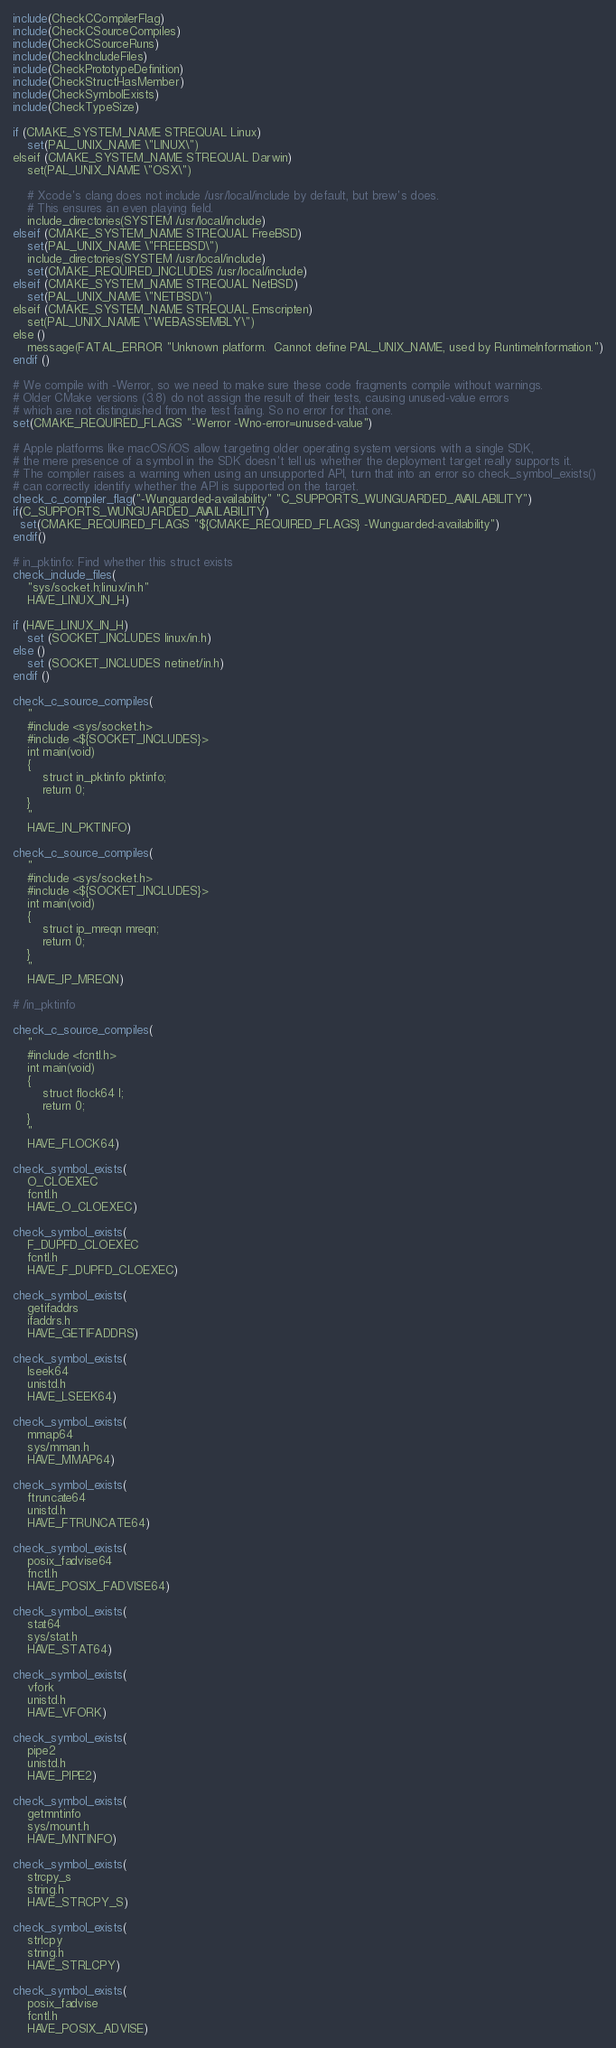Convert code to text. <code><loc_0><loc_0><loc_500><loc_500><_CMake_>include(CheckCCompilerFlag)
include(CheckCSourceCompiles)
include(CheckCSourceRuns)
include(CheckIncludeFiles)
include(CheckPrototypeDefinition)
include(CheckStructHasMember)
include(CheckSymbolExists)
include(CheckTypeSize)

if (CMAKE_SYSTEM_NAME STREQUAL Linux)
    set(PAL_UNIX_NAME \"LINUX\")
elseif (CMAKE_SYSTEM_NAME STREQUAL Darwin)
    set(PAL_UNIX_NAME \"OSX\")

    # Xcode's clang does not include /usr/local/include by default, but brew's does.
    # This ensures an even playing field.
    include_directories(SYSTEM /usr/local/include)
elseif (CMAKE_SYSTEM_NAME STREQUAL FreeBSD)
    set(PAL_UNIX_NAME \"FREEBSD\")
    include_directories(SYSTEM /usr/local/include)
    set(CMAKE_REQUIRED_INCLUDES /usr/local/include)
elseif (CMAKE_SYSTEM_NAME STREQUAL NetBSD)
    set(PAL_UNIX_NAME \"NETBSD\")
elseif (CMAKE_SYSTEM_NAME STREQUAL Emscripten)
    set(PAL_UNIX_NAME \"WEBASSEMBLY\")
else ()
    message(FATAL_ERROR "Unknown platform.  Cannot define PAL_UNIX_NAME, used by RuntimeInformation.")
endif ()

# We compile with -Werror, so we need to make sure these code fragments compile without warnings.
# Older CMake versions (3.8) do not assign the result of their tests, causing unused-value errors
# which are not distinguished from the test failing. So no error for that one.
set(CMAKE_REQUIRED_FLAGS "-Werror -Wno-error=unused-value")

# Apple platforms like macOS/iOS allow targeting older operating system versions with a single SDK,
# the mere presence of a symbol in the SDK doesn't tell us whether the deployment target really supports it.
# The compiler raises a warning when using an unsupported API, turn that into an error so check_symbol_exists()
# can correctly identify whether the API is supported on the target.
check_c_compiler_flag("-Wunguarded-availability" "C_SUPPORTS_WUNGUARDED_AVAILABILITY")
if(C_SUPPORTS_WUNGUARDED_AVAILABILITY)
  set(CMAKE_REQUIRED_FLAGS "${CMAKE_REQUIRED_FLAGS} -Wunguarded-availability")
endif()

# in_pktinfo: Find whether this struct exists
check_include_files(
    "sys/socket.h;linux/in.h"
    HAVE_LINUX_IN_H)

if (HAVE_LINUX_IN_H)
    set (SOCKET_INCLUDES linux/in.h)
else ()
    set (SOCKET_INCLUDES netinet/in.h)
endif ()

check_c_source_compiles(
    "
    #include <sys/socket.h>
    #include <${SOCKET_INCLUDES}>
    int main(void)
    {
        struct in_pktinfo pktinfo;
        return 0;
    }
    "
    HAVE_IN_PKTINFO)

check_c_source_compiles(
    "
    #include <sys/socket.h>
    #include <${SOCKET_INCLUDES}>
    int main(void)
    {
        struct ip_mreqn mreqn;
        return 0;
    }
    "
    HAVE_IP_MREQN)

# /in_pktinfo

check_c_source_compiles(
    "
    #include <fcntl.h>
    int main(void)
    {
        struct flock64 l;
        return 0;
    }
    "
    HAVE_FLOCK64)

check_symbol_exists(
    O_CLOEXEC
    fcntl.h
    HAVE_O_CLOEXEC)

check_symbol_exists(
    F_DUPFD_CLOEXEC
    fcntl.h
    HAVE_F_DUPFD_CLOEXEC)

check_symbol_exists(
    getifaddrs
    ifaddrs.h
    HAVE_GETIFADDRS)

check_symbol_exists(
    lseek64
    unistd.h
    HAVE_LSEEK64)

check_symbol_exists(
    mmap64
    sys/mman.h
    HAVE_MMAP64)

check_symbol_exists(
    ftruncate64
    unistd.h
    HAVE_FTRUNCATE64)

check_symbol_exists(
    posix_fadvise64
    fnctl.h
    HAVE_POSIX_FADVISE64)

check_symbol_exists(
    stat64
    sys/stat.h
    HAVE_STAT64)

check_symbol_exists(
    vfork
    unistd.h
    HAVE_VFORK)

check_symbol_exists(
    pipe2
    unistd.h
    HAVE_PIPE2)

check_symbol_exists(
    getmntinfo
    sys/mount.h
    HAVE_MNTINFO)

check_symbol_exists(
    strcpy_s
    string.h
    HAVE_STRCPY_S)

check_symbol_exists(
    strlcpy
    string.h
    HAVE_STRLCPY)

check_symbol_exists(
    posix_fadvise
    fcntl.h
    HAVE_POSIX_ADVISE)
</code> 